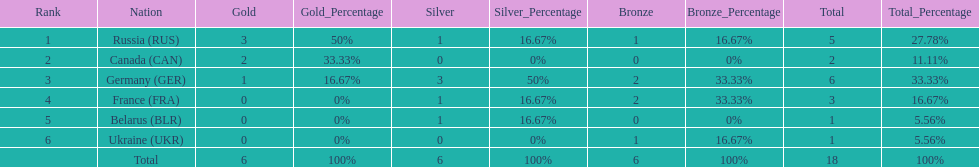What was the total number of silver medals awarded to the french and the germans in the 1994 winter olympic biathlon? 4. 